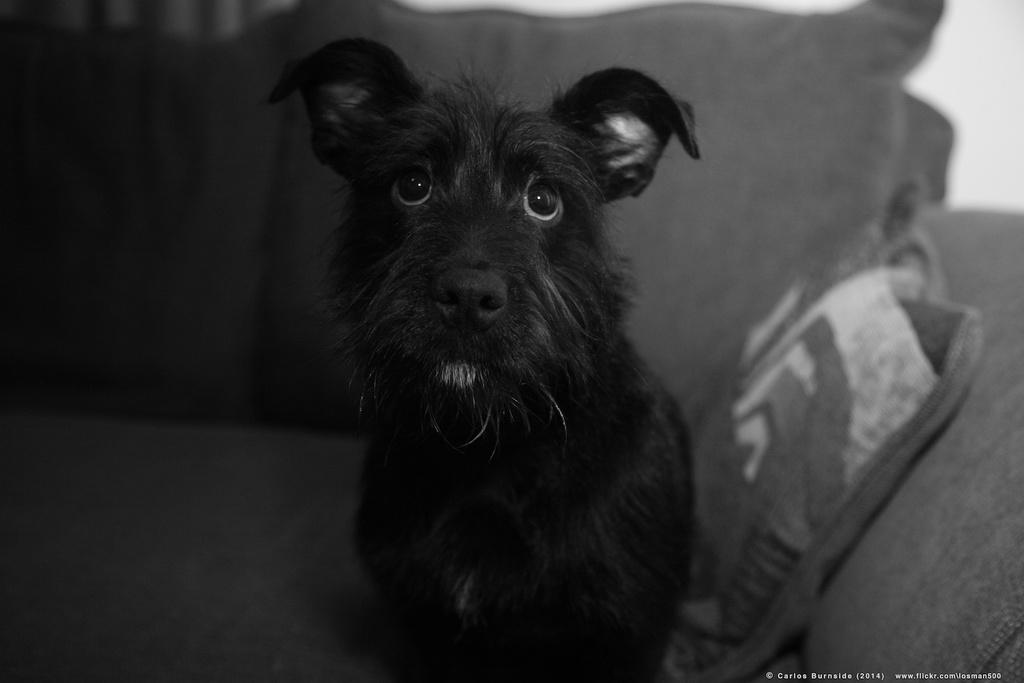What is the color scheme of the image? The image is black and white. What animal can be seen in the image? There is a dog in the image. Where is the dog located? The dog is on a sofa. What other object is present in the image? There is a pillow in the image. What type of secretary is working on the story in the image? There is no secretary or story present in the image; it features a dog on a sofa and a pillow. 